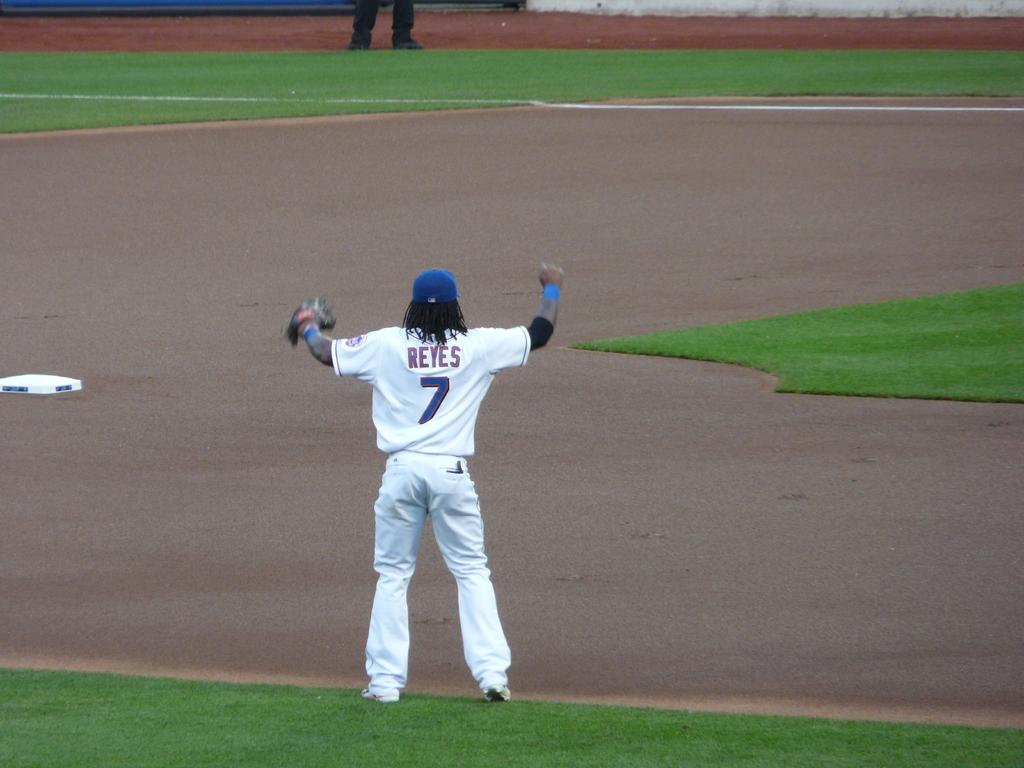<image>
Create a compact narrative representing the image presented. a player with the name Reyes on their jersey 